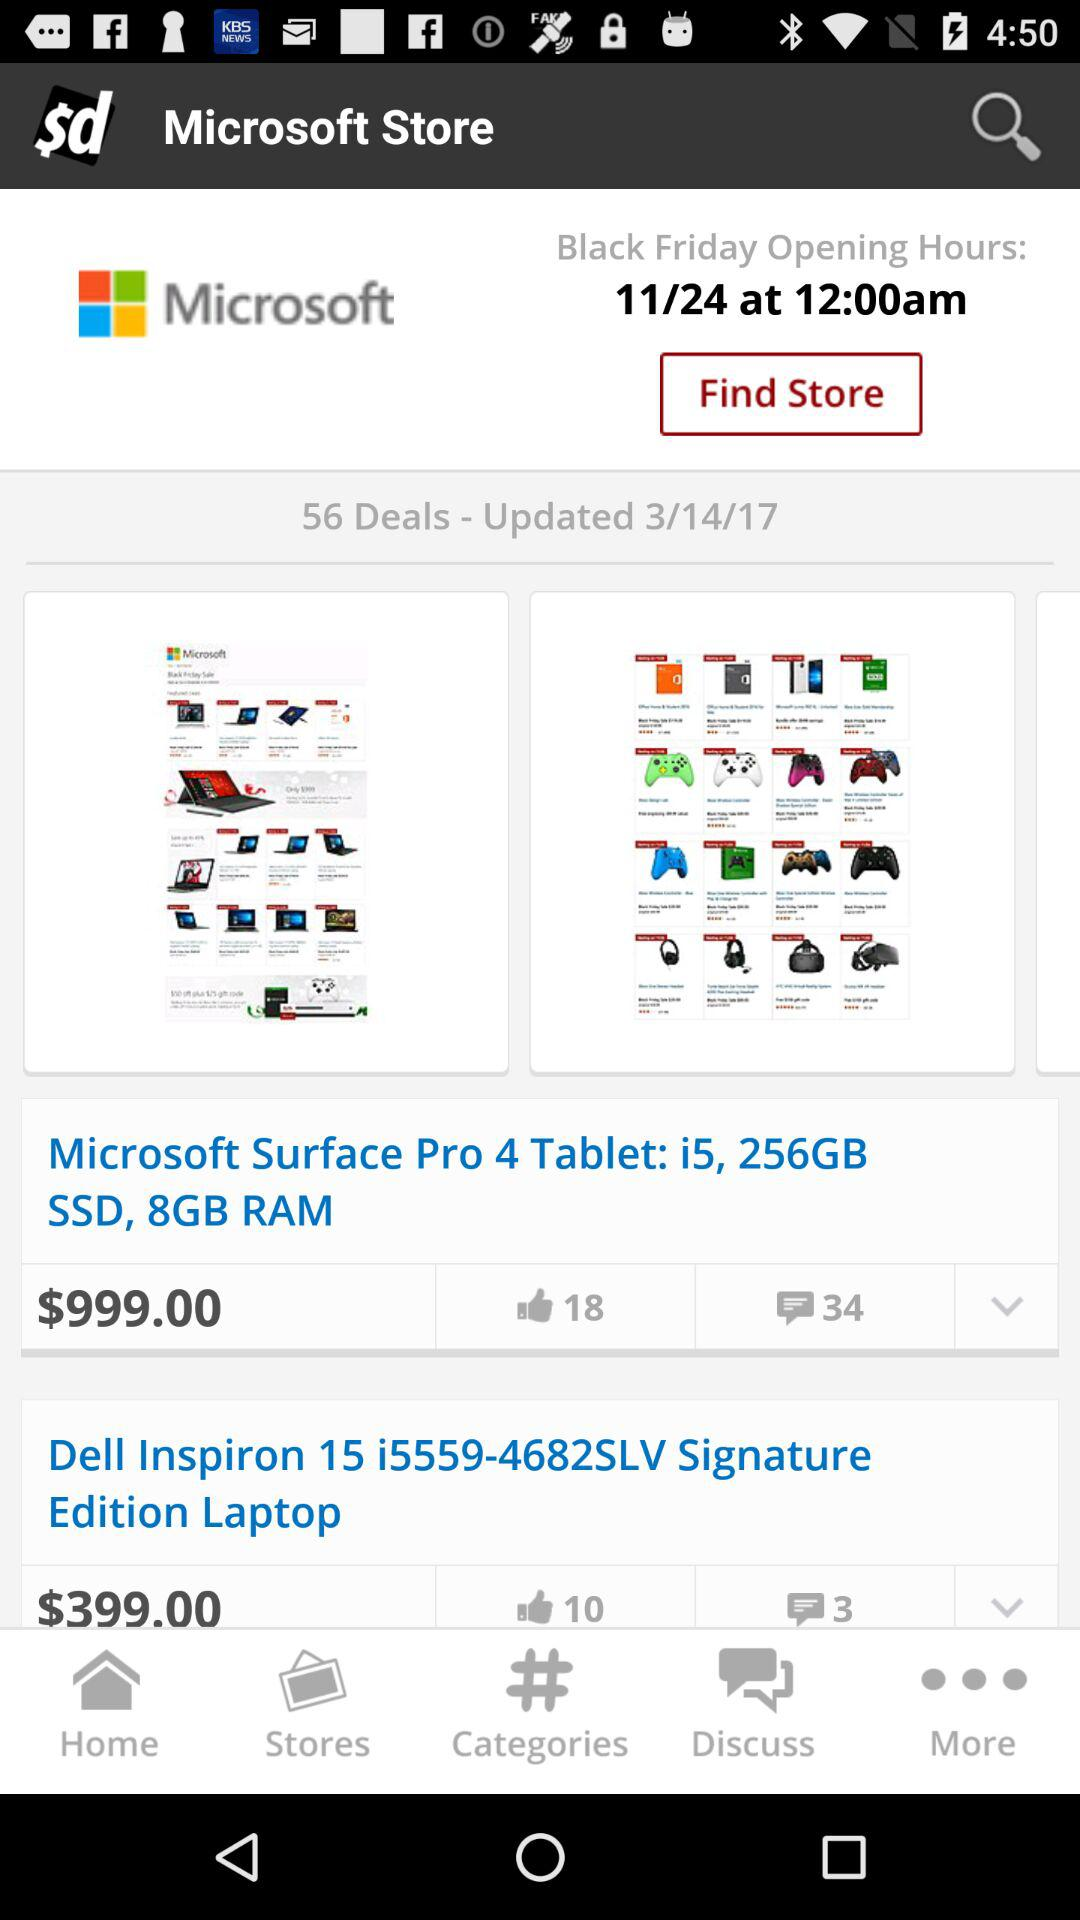When were the deals updated last? The deals were last updated on March 14, 2017. 